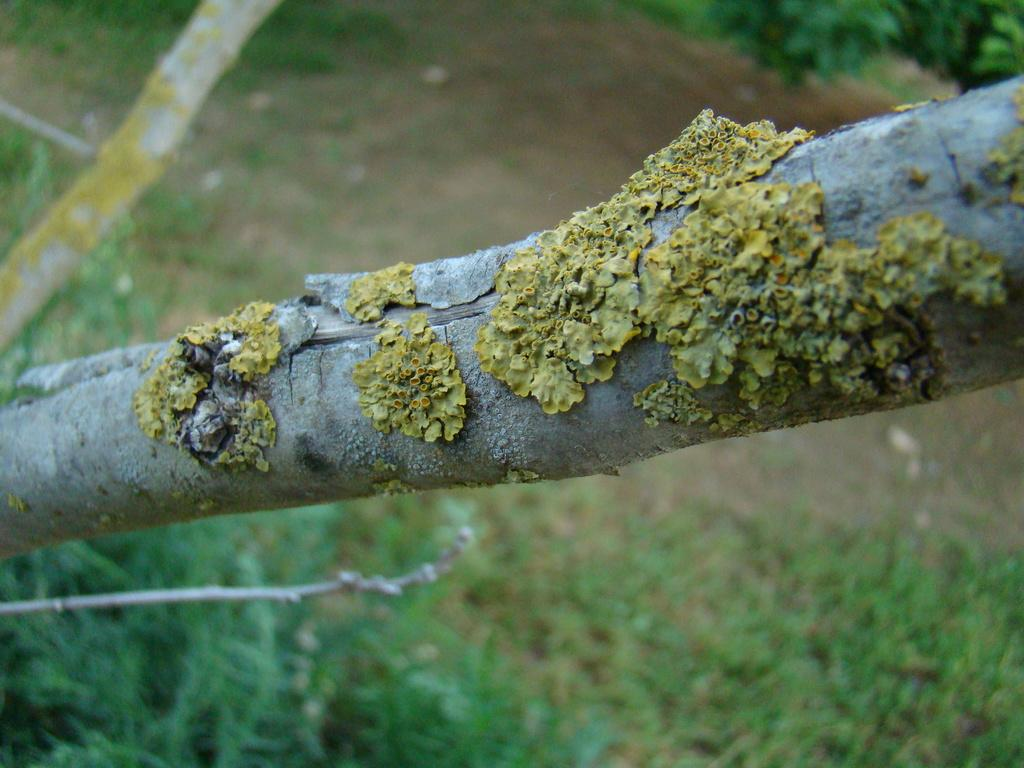What type of natural object can be seen in the image? There is a branch in the image. What type of surface is visible in the image? There is ground visible in the image. What type of vegetation is present in the image? There is grass and plants visible in the image. What is the cause of the dog's excitement in the image? There is no dog present in the image, so it is not possible to determine the cause of any excitement. --- Facts: 1. There is a person in the image. 2. The person is holding a book. 3. The person is sitting on a chair. 4. There is a table in the image. 5. There is a lamp on the table in the image. Absurd Topics: ocean, volcano, airplane Conversation: What is the person in the image doing? The person in the image is holding a book. What is the person sitting on in the image? The person is sitting on a chair. What is present on the table in the image? There is a lamp on the table in the image. Reasoning: Let's think step by step in order to produce the conversation. We start by identifying the main subject in the image, which is the person. Then, we expand the conversation to include other elements of the image, such as the book, the chair, and the table. Each question is designed to elicit a specific detail about the image that is known from the provided facts. Absurd Question/Answer: Can you see the ocean in the image? There is no ocean present in the image. Is there a volcano visible in the image? There is no volcano present in the image. 